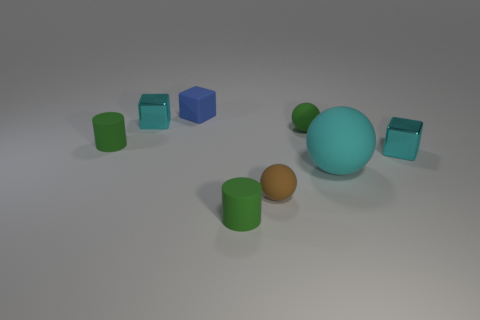Add 2 gray metal blocks. How many objects exist? 10 Subtract all cubes. How many objects are left? 5 Subtract 1 cyan blocks. How many objects are left? 7 Subtract all small cylinders. Subtract all big cyan spheres. How many objects are left? 5 Add 3 small green matte spheres. How many small green matte spheres are left? 4 Add 7 large spheres. How many large spheres exist? 8 